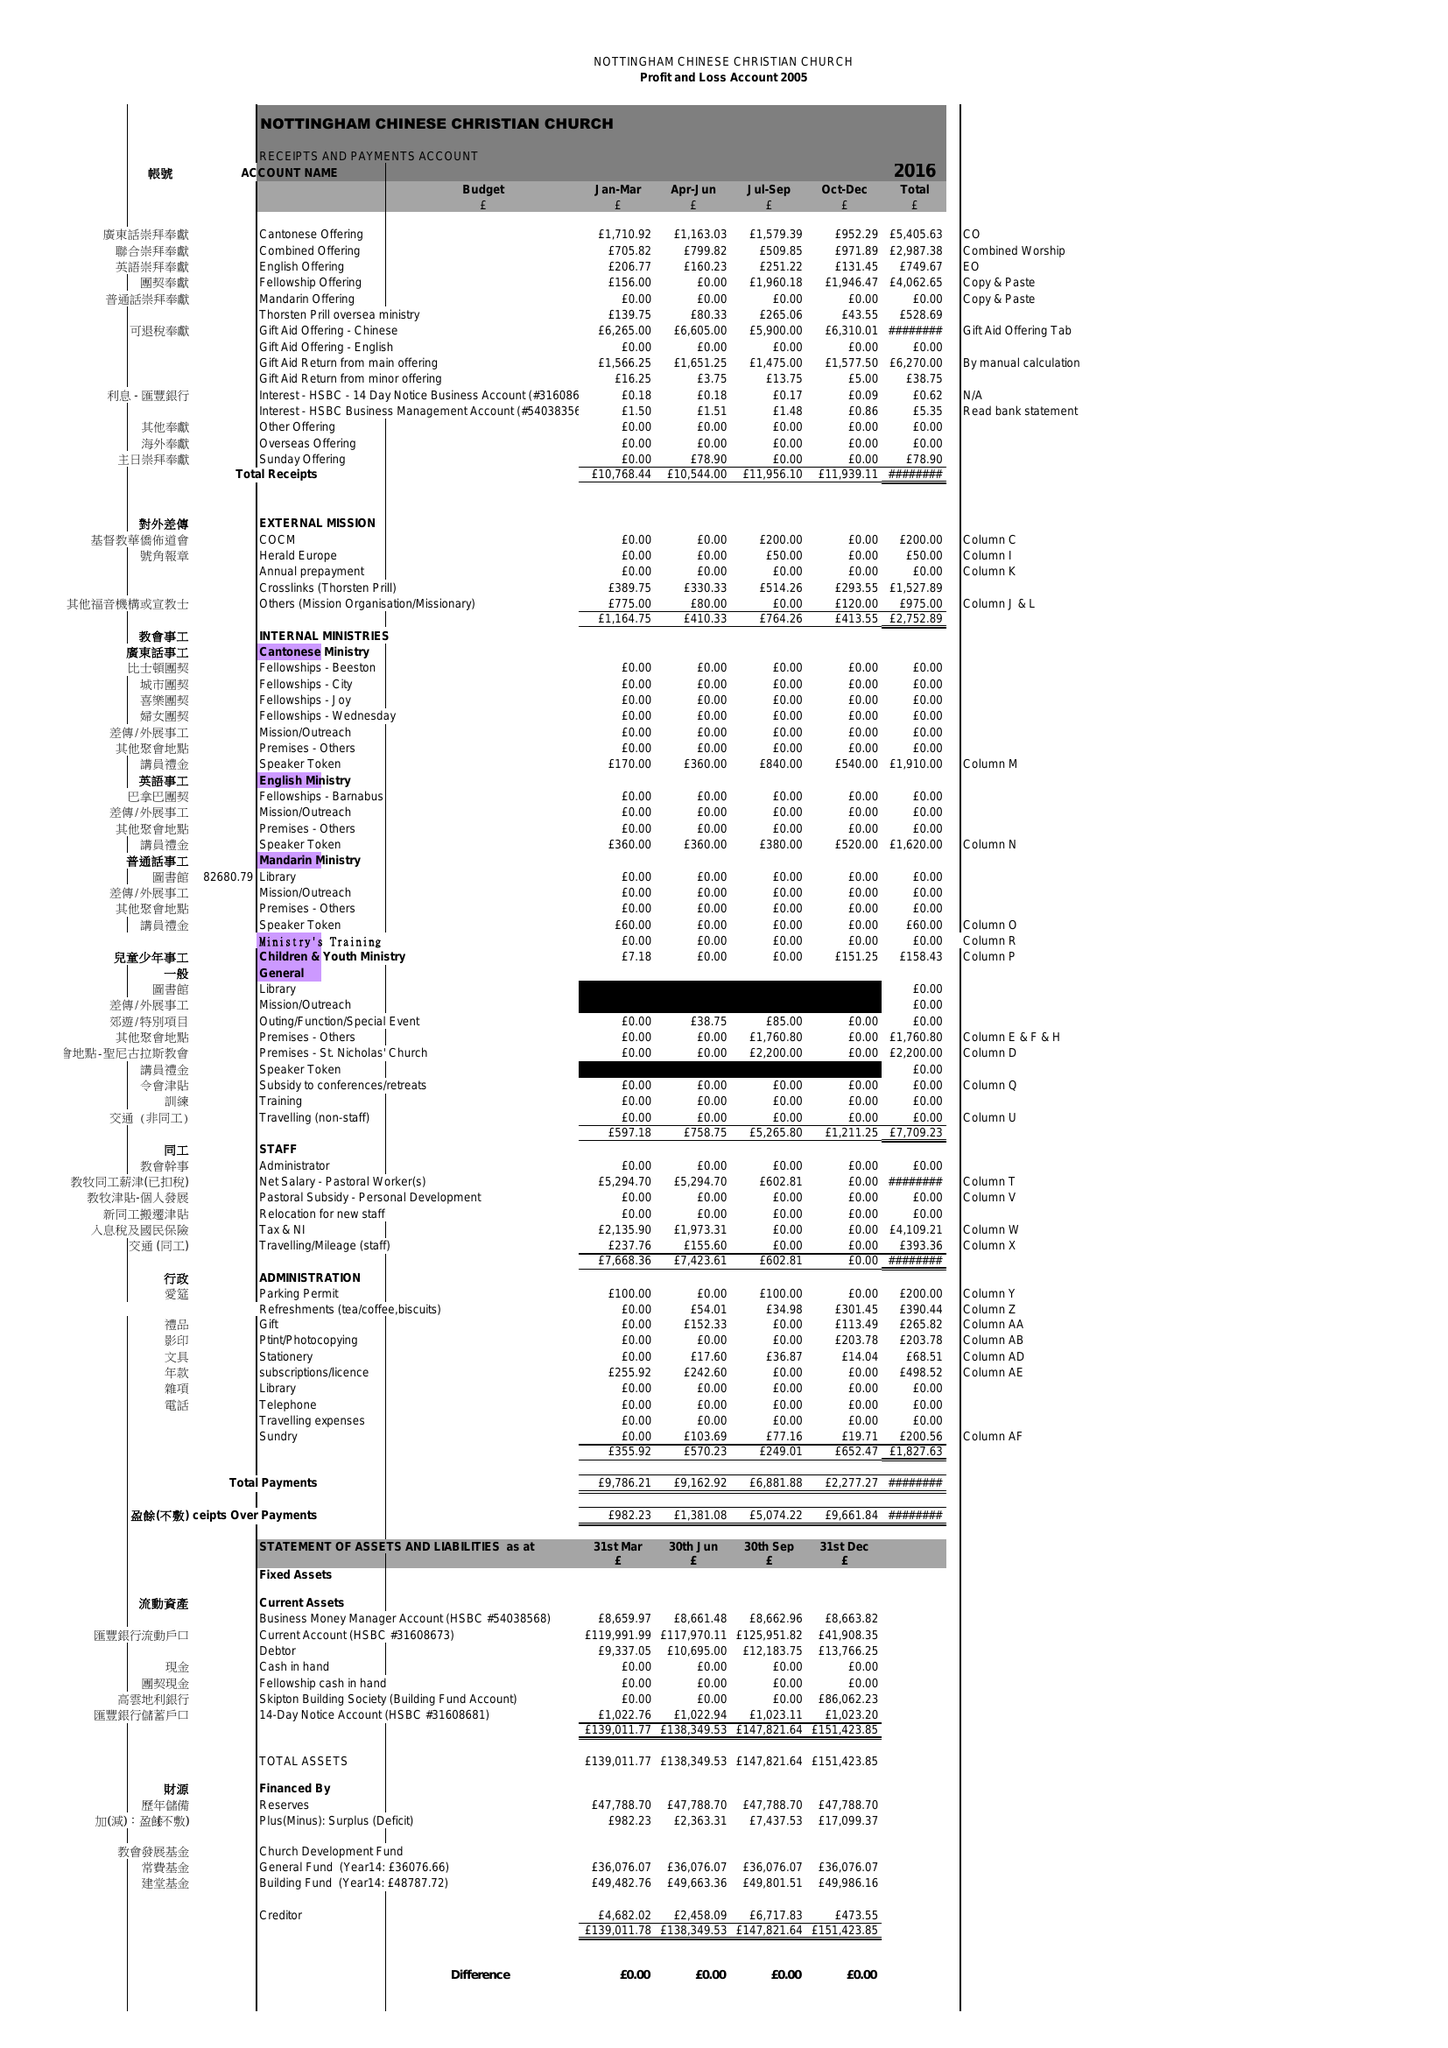What is the value for the address__street_line?
Answer the question using a single word or phrase. 79 MAID MARIAN WAY 